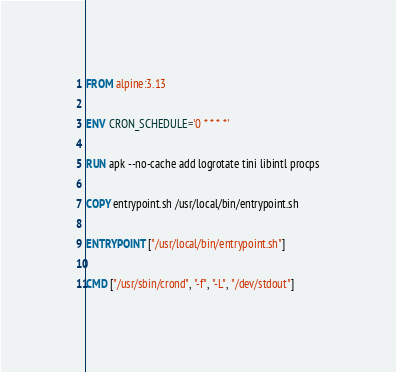Convert code to text. <code><loc_0><loc_0><loc_500><loc_500><_Dockerfile_>FROM alpine:3.13

ENV CRON_SCHEDULE='0 * * * *'

RUN apk --no-cache add logrotate tini libintl procps

COPY entrypoint.sh /usr/local/bin/entrypoint.sh

ENTRYPOINT ["/usr/local/bin/entrypoint.sh"]

CMD ["/usr/sbin/crond", "-f", "-L", "/dev/stdout"]
</code> 